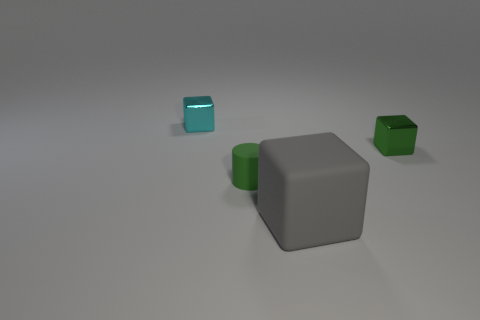Subtract all gray blocks. How many blocks are left? 2 Add 1 green objects. How many objects exist? 5 Subtract all green blocks. How many blocks are left? 2 Subtract all cubes. How many objects are left? 1 Subtract 0 green spheres. How many objects are left? 4 Subtract 2 cubes. How many cubes are left? 1 Subtract all yellow blocks. Subtract all yellow balls. How many blocks are left? 3 Subtract all large green things. Subtract all tiny green rubber objects. How many objects are left? 3 Add 4 cyan cubes. How many cyan cubes are left? 5 Add 2 blocks. How many blocks exist? 5 